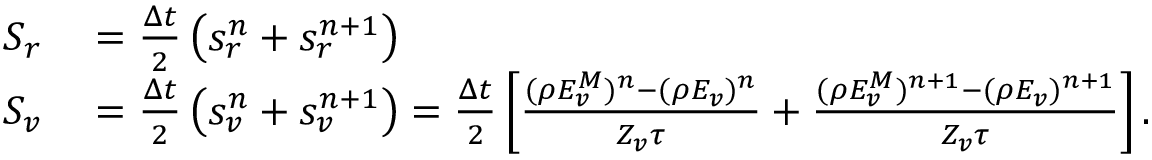Convert formula to latex. <formula><loc_0><loc_0><loc_500><loc_500>\begin{array} { r l } { S _ { r } } & = \frac { \Delta t } { 2 } \left ( s _ { r } ^ { n } + s _ { r } ^ { n + 1 } \right ) } \\ { S _ { v } } & = \frac { \Delta t } { 2 } \left ( s _ { v } ^ { n } + s _ { v } ^ { n + 1 } \right ) = \frac { \Delta t } { 2 } \left [ \frac { ( \rho E _ { v } ^ { M } ) ^ { n } - ( \rho E _ { v } ) ^ { n } } { Z _ { v } \tau } + \frac { ( \rho E _ { v } ^ { M } ) ^ { n + 1 } - ( \rho E _ { v } ) ^ { n + 1 } } { Z _ { v } \tau } \right ] . } \end{array}</formula> 